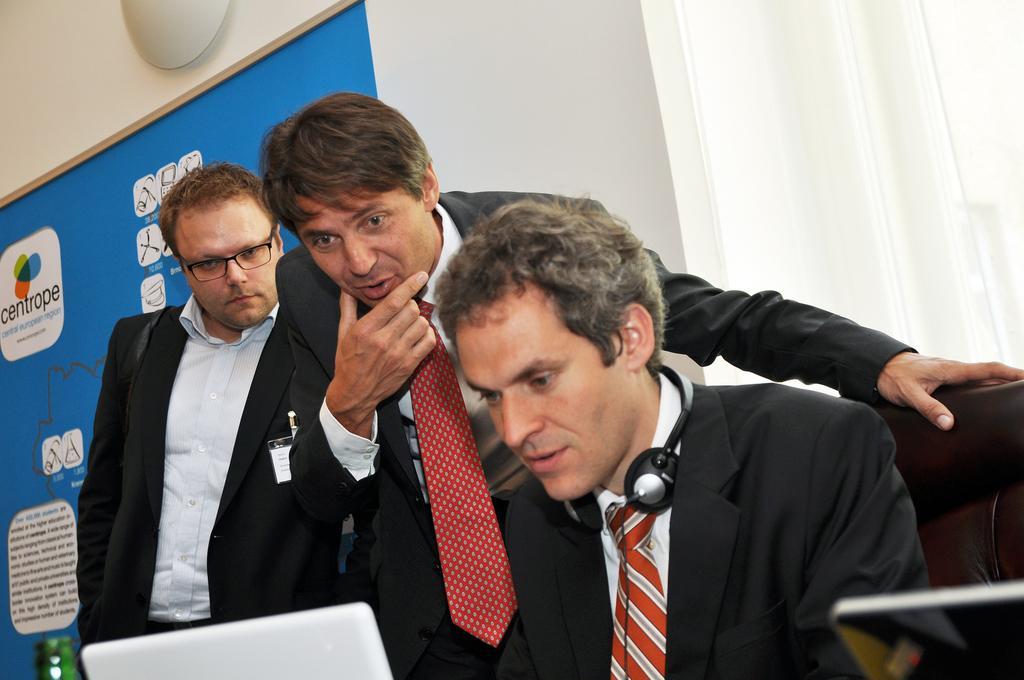Could you give a brief overview of what you see in this image? In this picture we can see three men wearing black suits, sitting and working on the laptop. Behind there is a blue banner board and white wall. 